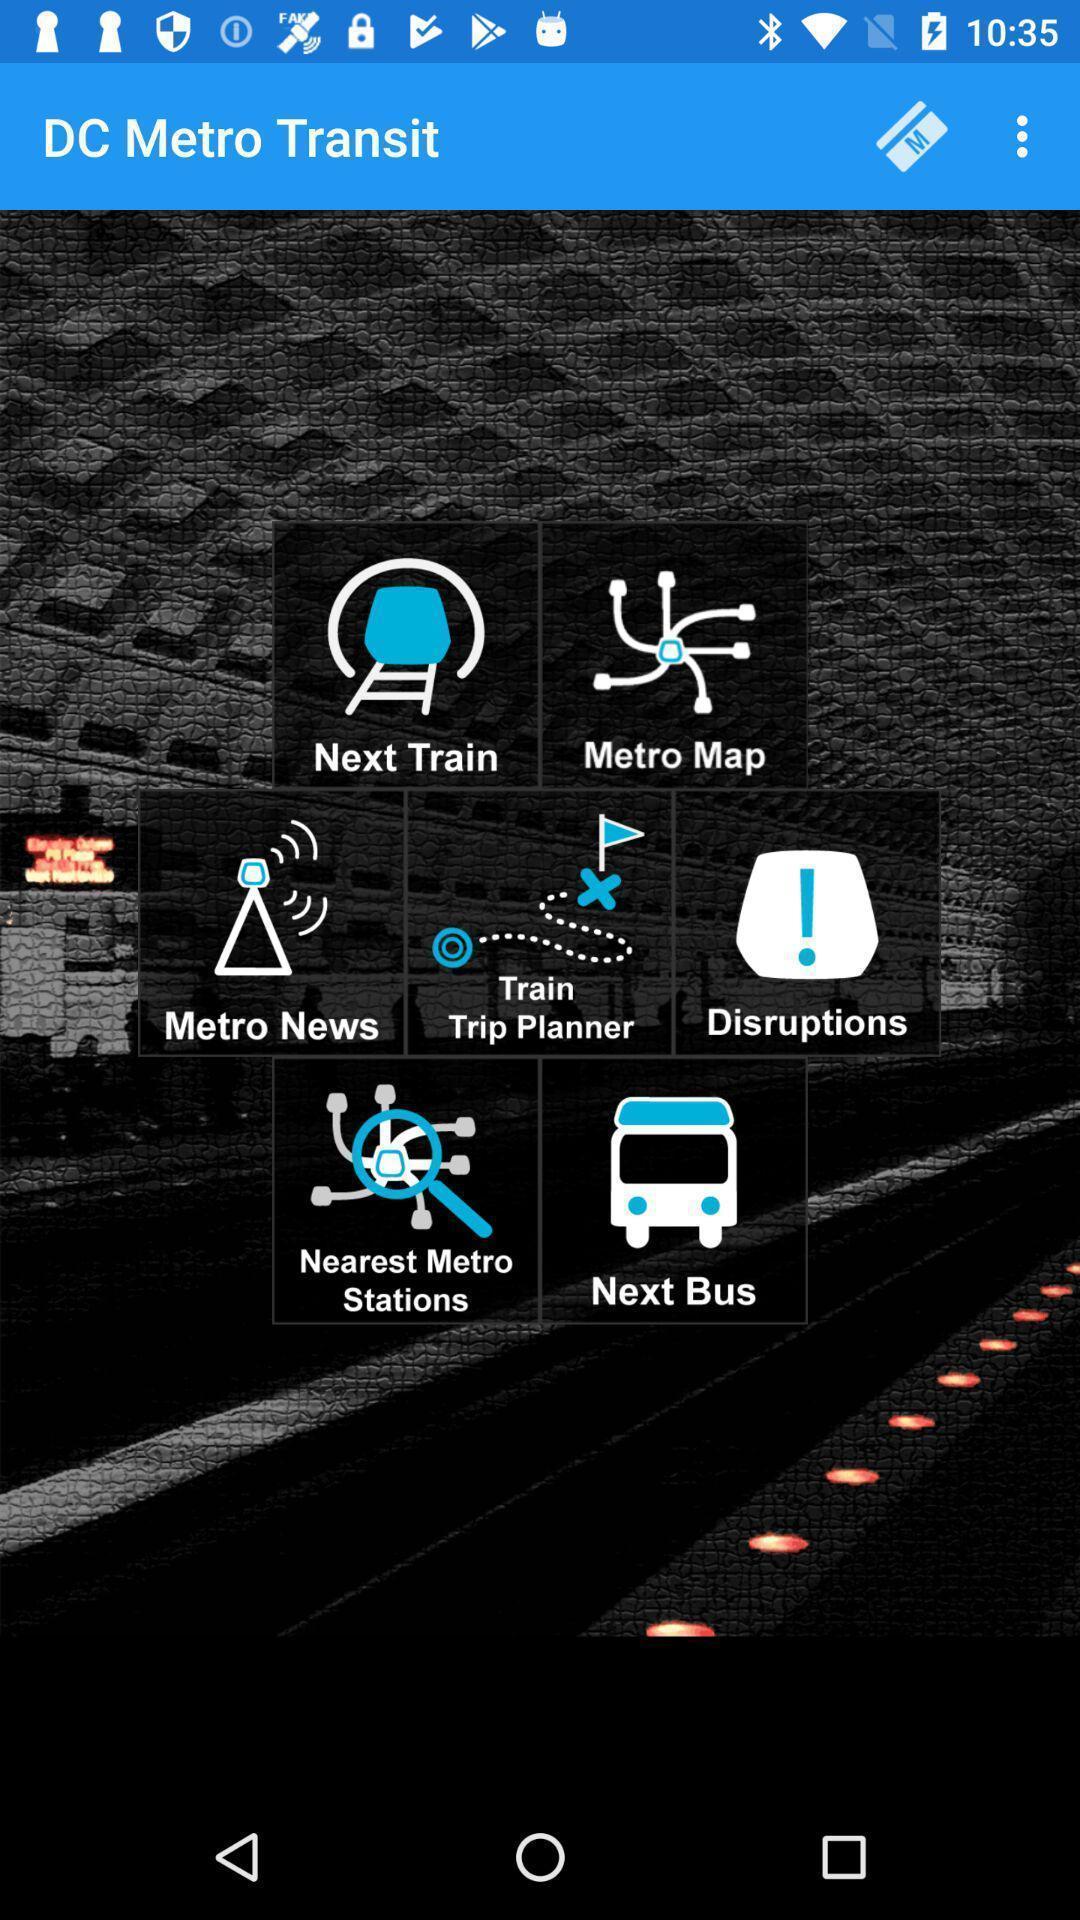What details can you identify in this image? Page displaying various options of an automobile app. 